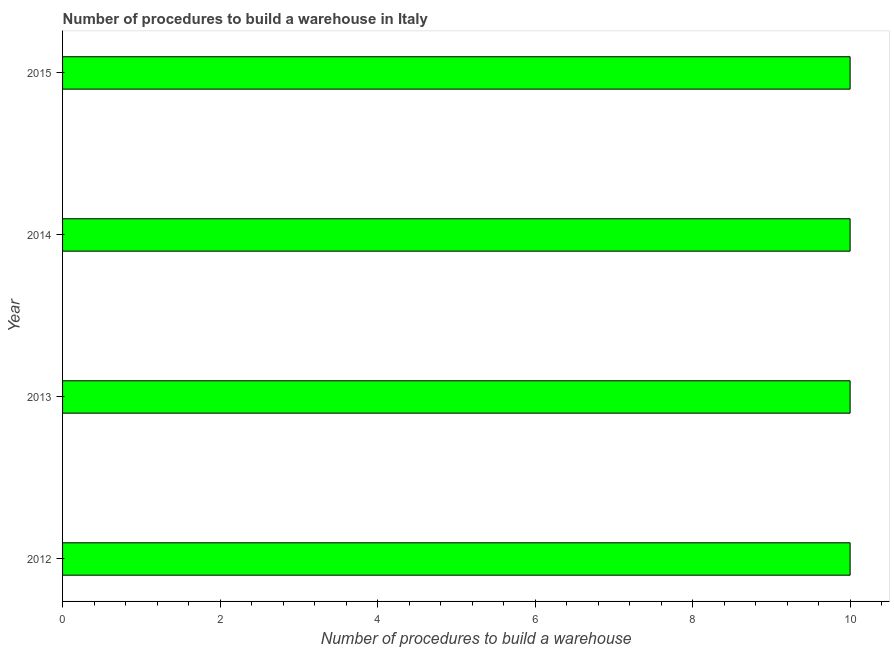Does the graph contain any zero values?
Offer a very short reply. No. What is the title of the graph?
Your answer should be compact. Number of procedures to build a warehouse in Italy. What is the label or title of the X-axis?
Make the answer very short. Number of procedures to build a warehouse. What is the label or title of the Y-axis?
Make the answer very short. Year. Across all years, what is the minimum number of procedures to build a warehouse?
Your answer should be compact. 10. In which year was the number of procedures to build a warehouse maximum?
Provide a short and direct response. 2012. In which year was the number of procedures to build a warehouse minimum?
Keep it short and to the point. 2012. What is the sum of the number of procedures to build a warehouse?
Make the answer very short. 40. What is the difference between the number of procedures to build a warehouse in 2013 and 2015?
Give a very brief answer. 0. What is the average number of procedures to build a warehouse per year?
Provide a short and direct response. 10. What is the median number of procedures to build a warehouse?
Keep it short and to the point. 10. What is the ratio of the number of procedures to build a warehouse in 2013 to that in 2015?
Offer a terse response. 1. What is the difference between the highest and the lowest number of procedures to build a warehouse?
Offer a terse response. 0. In how many years, is the number of procedures to build a warehouse greater than the average number of procedures to build a warehouse taken over all years?
Provide a succinct answer. 0. How many bars are there?
Give a very brief answer. 4. Are all the bars in the graph horizontal?
Your answer should be very brief. Yes. What is the difference between two consecutive major ticks on the X-axis?
Offer a terse response. 2. What is the Number of procedures to build a warehouse of 2013?
Ensure brevity in your answer.  10. What is the Number of procedures to build a warehouse in 2015?
Provide a succinct answer. 10. What is the difference between the Number of procedures to build a warehouse in 2012 and 2013?
Ensure brevity in your answer.  0. What is the difference between the Number of procedures to build a warehouse in 2012 and 2014?
Your answer should be compact. 0. What is the difference between the Number of procedures to build a warehouse in 2014 and 2015?
Offer a terse response. 0. What is the ratio of the Number of procedures to build a warehouse in 2012 to that in 2013?
Your response must be concise. 1. What is the ratio of the Number of procedures to build a warehouse in 2012 to that in 2014?
Your answer should be very brief. 1. What is the ratio of the Number of procedures to build a warehouse in 2013 to that in 2014?
Make the answer very short. 1. What is the ratio of the Number of procedures to build a warehouse in 2013 to that in 2015?
Make the answer very short. 1. What is the ratio of the Number of procedures to build a warehouse in 2014 to that in 2015?
Your answer should be very brief. 1. 